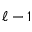Convert formula to latex. <formula><loc_0><loc_0><loc_500><loc_500>\ell - 1</formula> 